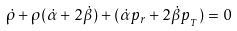<formula> <loc_0><loc_0><loc_500><loc_500>\dot { \rho } + \rho ( \dot { \alpha } + 2 \dot { \beta } ) + ( \dot { \alpha } p _ { r } + 2 \dot { \beta } p _ { _ { T } } ) = 0</formula> 